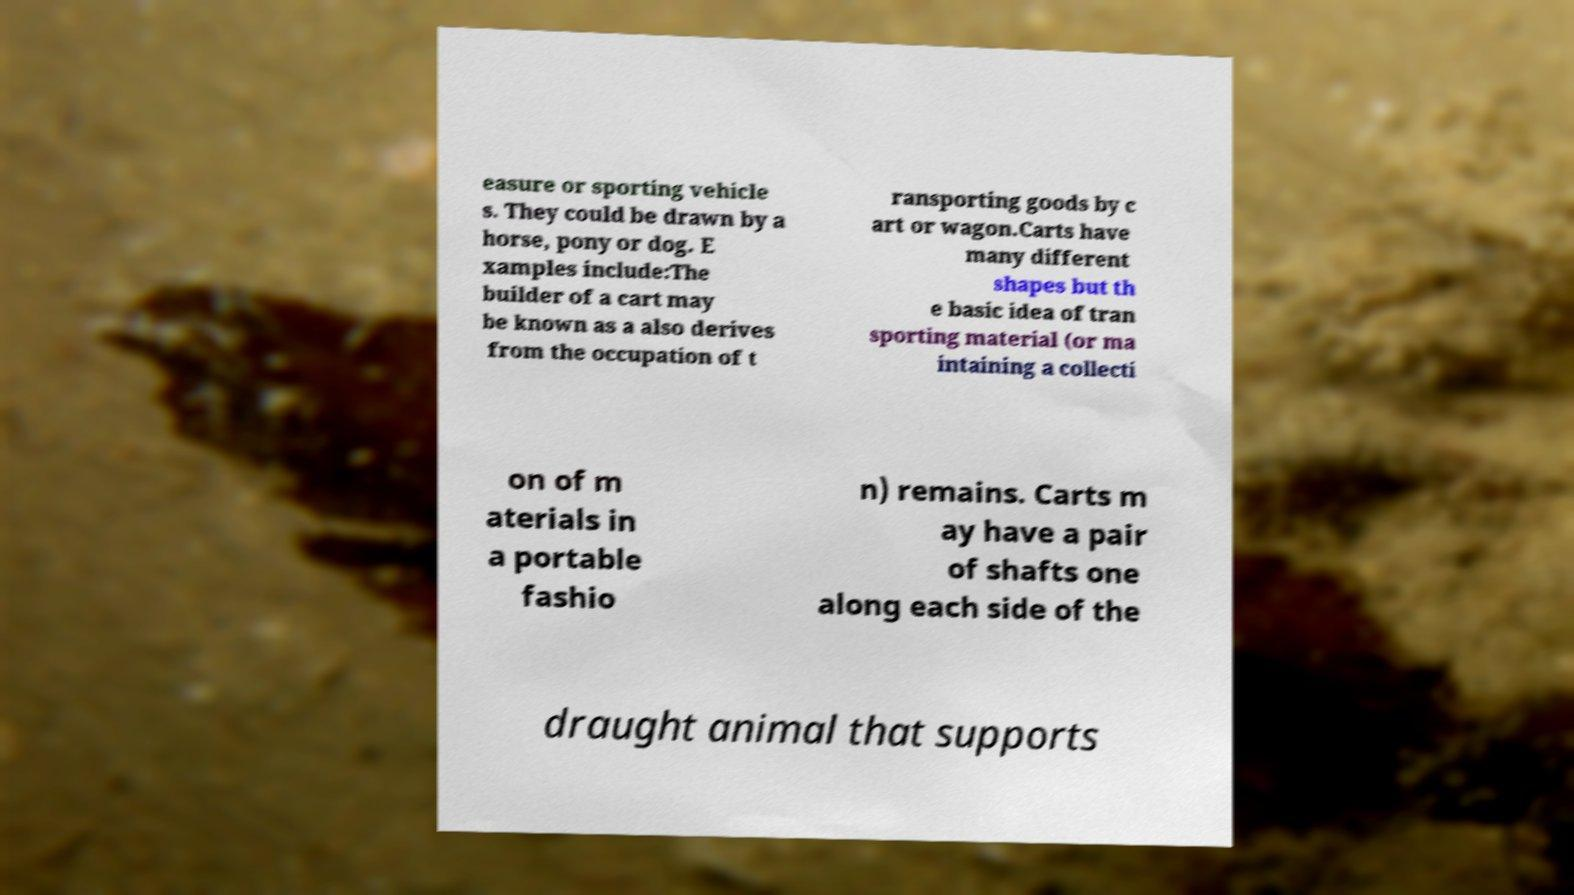Please read and relay the text visible in this image. What does it say? easure or sporting vehicle s. They could be drawn by a horse, pony or dog. E xamples include:The builder of a cart may be known as a also derives from the occupation of t ransporting goods by c art or wagon.Carts have many different shapes but th e basic idea of tran sporting material (or ma intaining a collecti on of m aterials in a portable fashio n) remains. Carts m ay have a pair of shafts one along each side of the draught animal that supports 